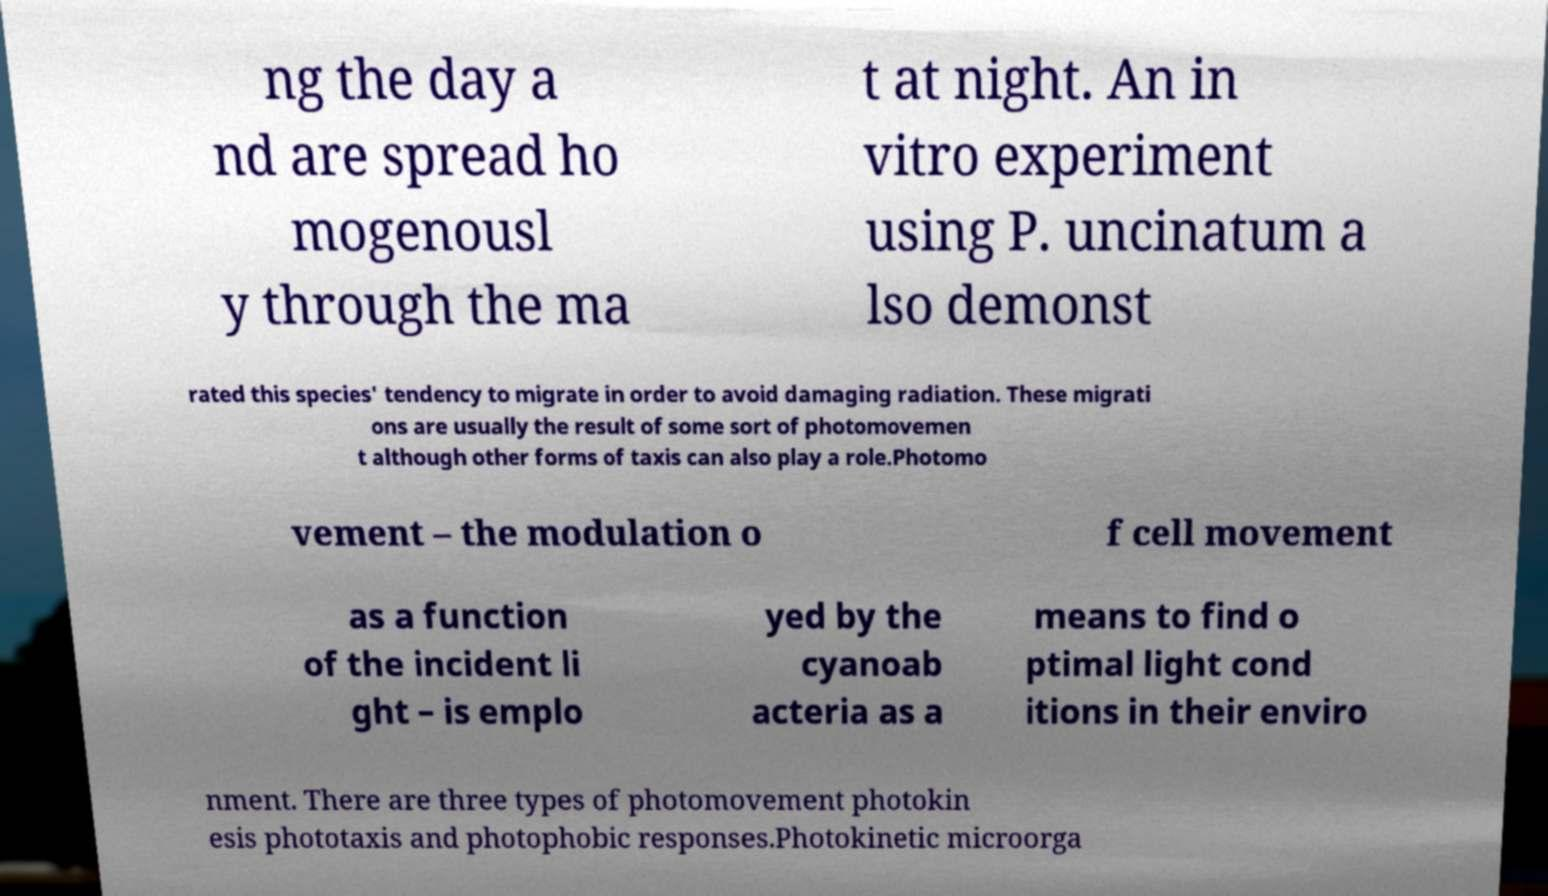Please read and relay the text visible in this image. What does it say? ng the day a nd are spread ho mogenousl y through the ma t at night. An in vitro experiment using P. uncinatum a lso demonst rated this species' tendency to migrate in order to avoid damaging radiation. These migrati ons are usually the result of some sort of photomovemen t although other forms of taxis can also play a role.Photomo vement – the modulation o f cell movement as a function of the incident li ght – is emplo yed by the cyanoab acteria as a means to find o ptimal light cond itions in their enviro nment. There are three types of photomovement photokin esis phototaxis and photophobic responses.Photokinetic microorga 